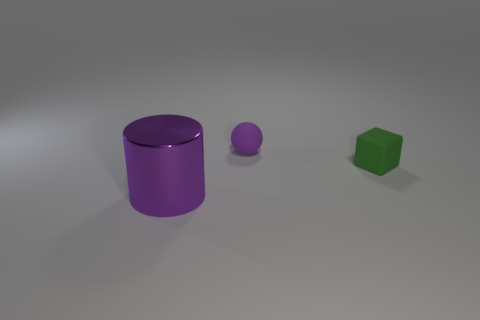Are there any other things that are the same size as the shiny cylinder?
Provide a succinct answer. No. Is the color of the tiny ball the same as the metallic cylinder?
Keep it short and to the point. Yes. What shape is the thing that is behind the cylinder and in front of the small purple sphere?
Your response must be concise. Cube. Is the number of purple rubber balls that are behind the tiny green thing greater than the number of large yellow rubber cubes?
Your answer should be very brief. Yes. What number of spheres are the same color as the block?
Your response must be concise. 0. There is a metal cylinder in front of the matte ball; is its color the same as the small sphere?
Your response must be concise. Yes. Are there the same number of rubber spheres left of the tiny matte ball and matte cubes that are on the right side of the block?
Your answer should be compact. Yes. Is there any other thing that is made of the same material as the cylinder?
Give a very brief answer. No. There is a small object that is to the left of the matte block; what is its color?
Offer a terse response. Purple. Are there the same number of purple shiny things that are in front of the big purple metal thing and big cyan rubber blocks?
Make the answer very short. Yes. 